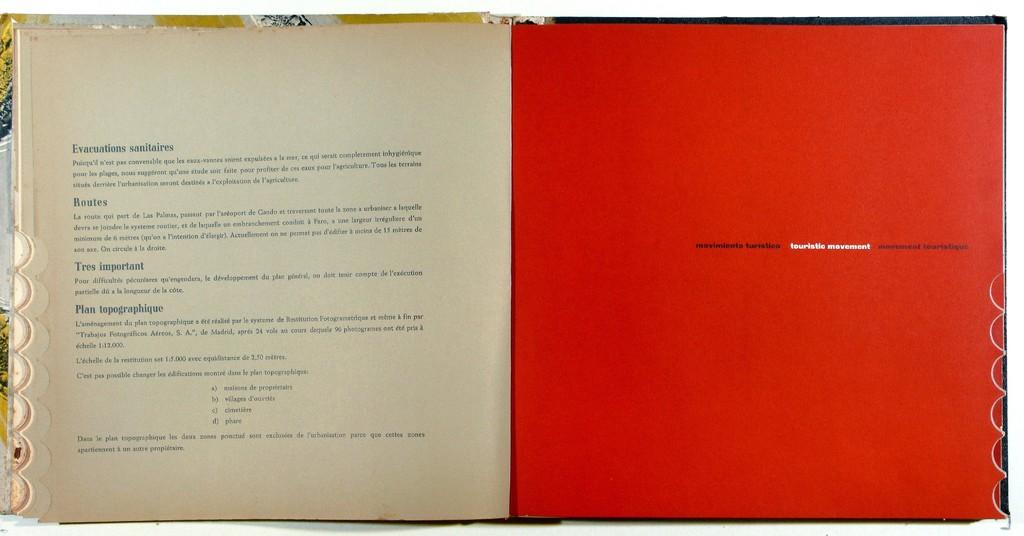<image>
Render a clear and concise summary of the photo. The words in white on the orange page are touristic movement. 